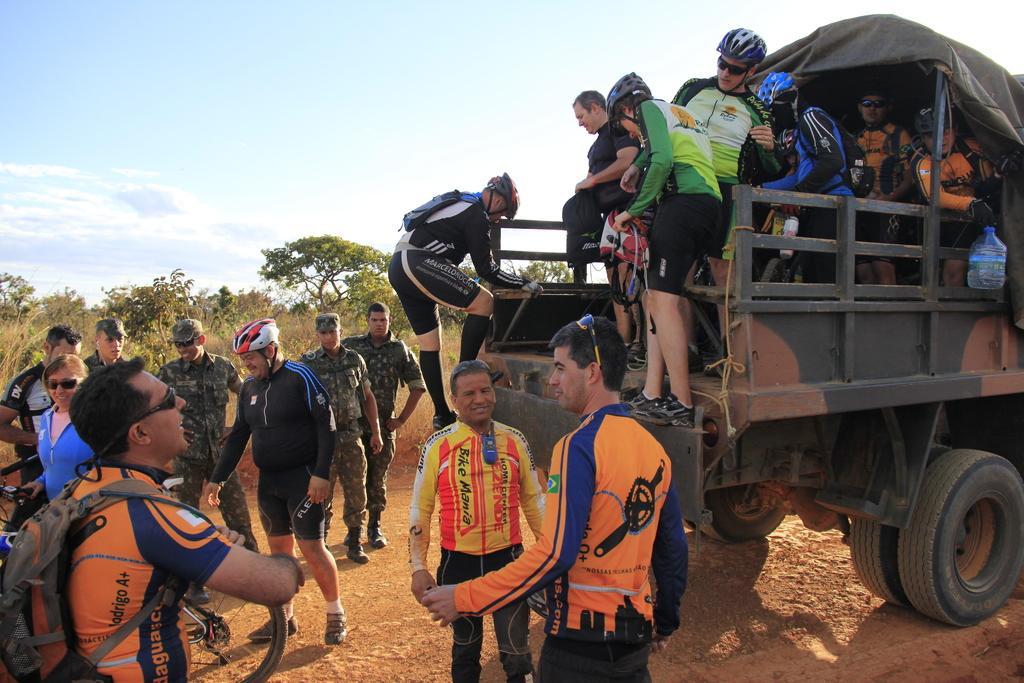In one or two sentences, can you explain what this image depicts? In this picture we can see a vehicle with some people, water can on it and some people standing, bicycle on the ground and some people wore helmets, caps, goggles and smiling and in the background we can see trees, sky. 